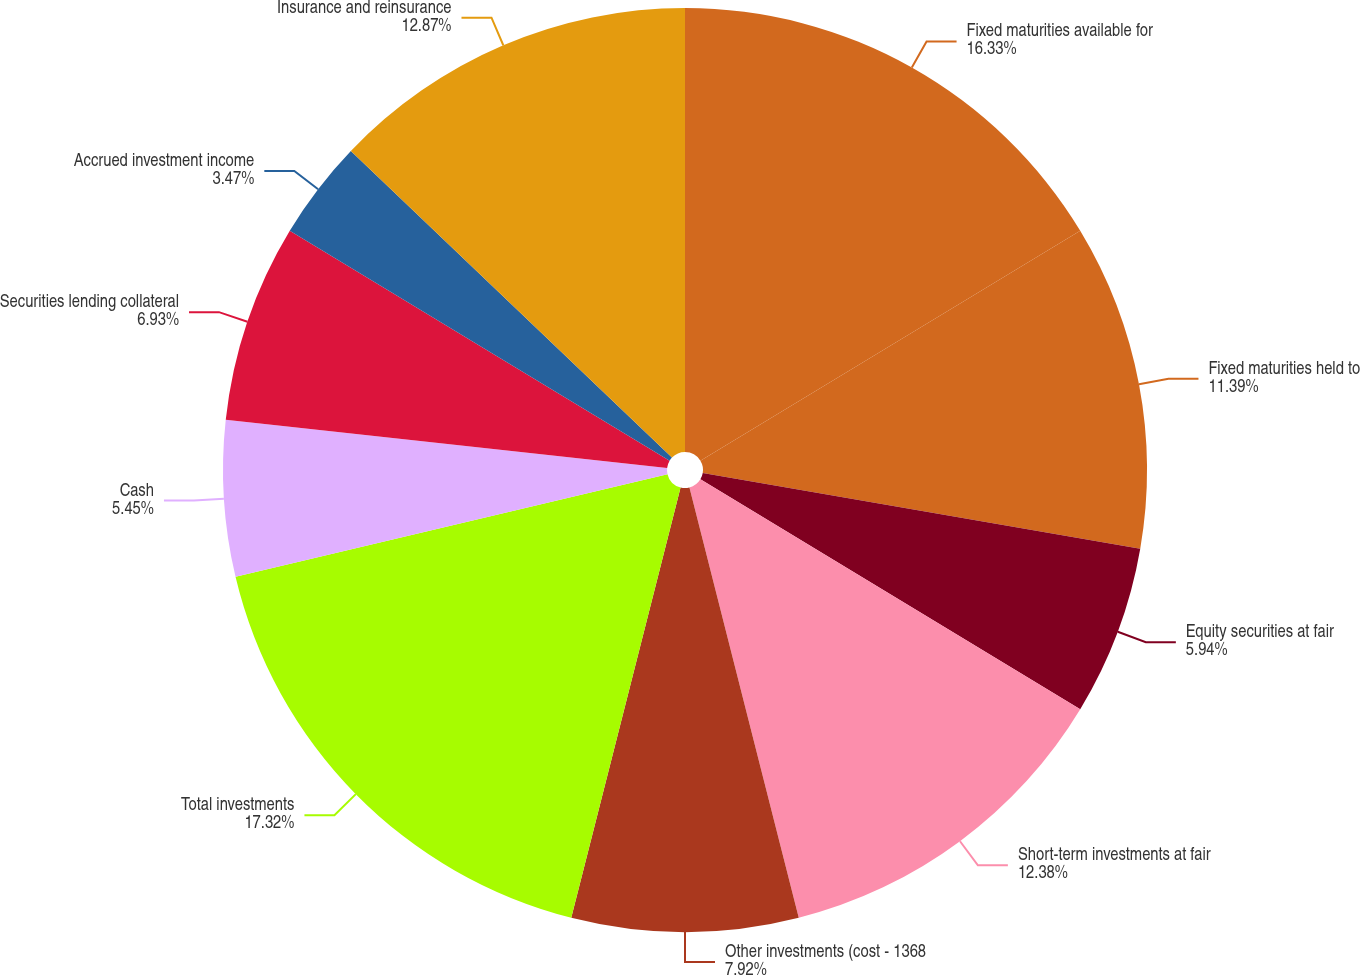<chart> <loc_0><loc_0><loc_500><loc_500><pie_chart><fcel>Fixed maturities available for<fcel>Fixed maturities held to<fcel>Equity securities at fair<fcel>Short-term investments at fair<fcel>Other investments (cost - 1368<fcel>Total investments<fcel>Cash<fcel>Securities lending collateral<fcel>Accrued investment income<fcel>Insurance and reinsurance<nl><fcel>16.34%<fcel>11.39%<fcel>5.94%<fcel>12.38%<fcel>7.92%<fcel>17.33%<fcel>5.45%<fcel>6.93%<fcel>3.47%<fcel>12.87%<nl></chart> 